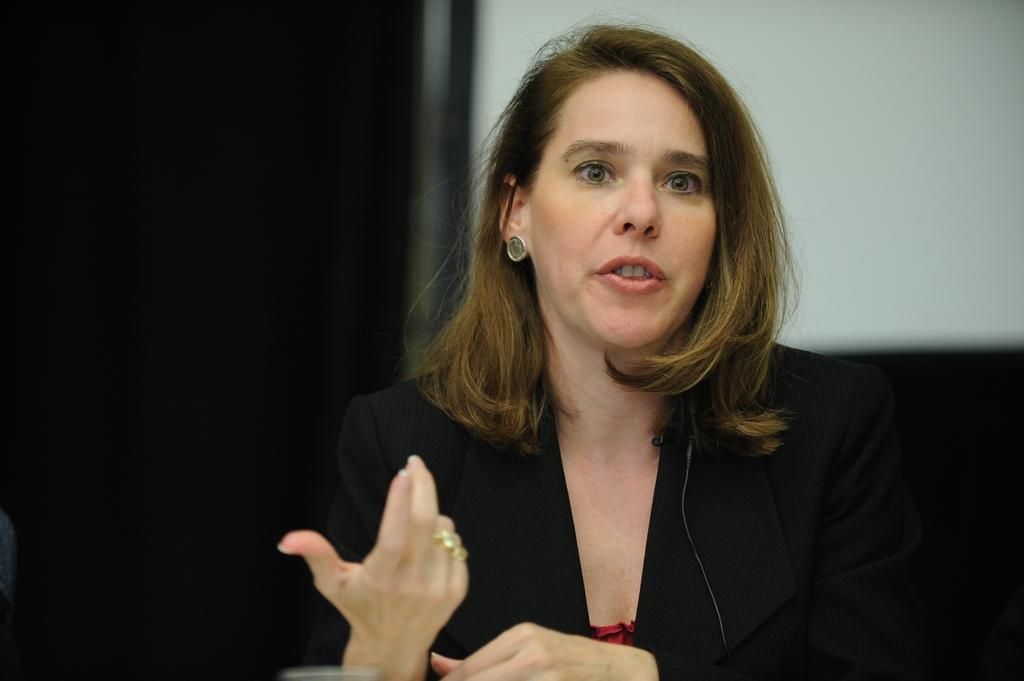Who is the main subject in the image? There is a woman in the image. What is the woman wearing? The woman is wearing a black suit. Where is the woman positioned in the image? The woman is standing in the front. What is the woman doing in the image? The woman appears to be speaking. What can be seen in the background of the image? There is a white wall in the background, and the background is dark. What type of pail can be seen in the image? There is no pail present in the image. What kind of cloud can be seen in the image? There are no clouds visible in the image, as the background is a dark wall. 